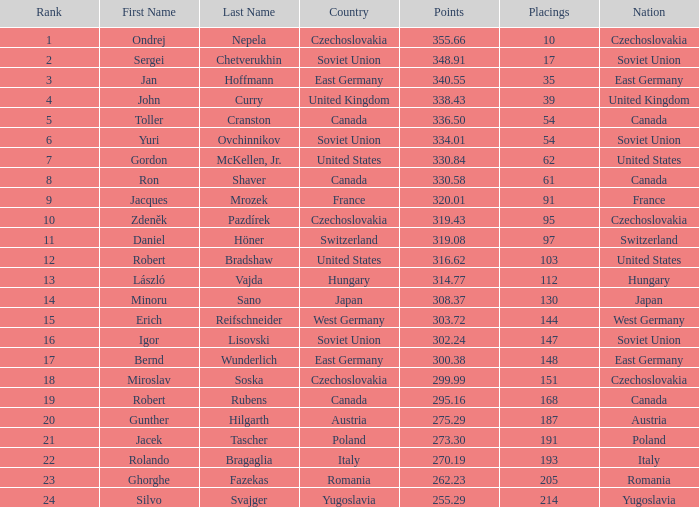In which nation is the point value 300.38? East Germany. 